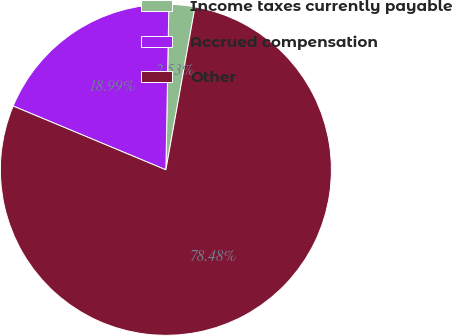Convert chart to OTSL. <chart><loc_0><loc_0><loc_500><loc_500><pie_chart><fcel>Income taxes currently payable<fcel>Accrued compensation<fcel>Other<nl><fcel>2.53%<fcel>18.99%<fcel>78.48%<nl></chart> 